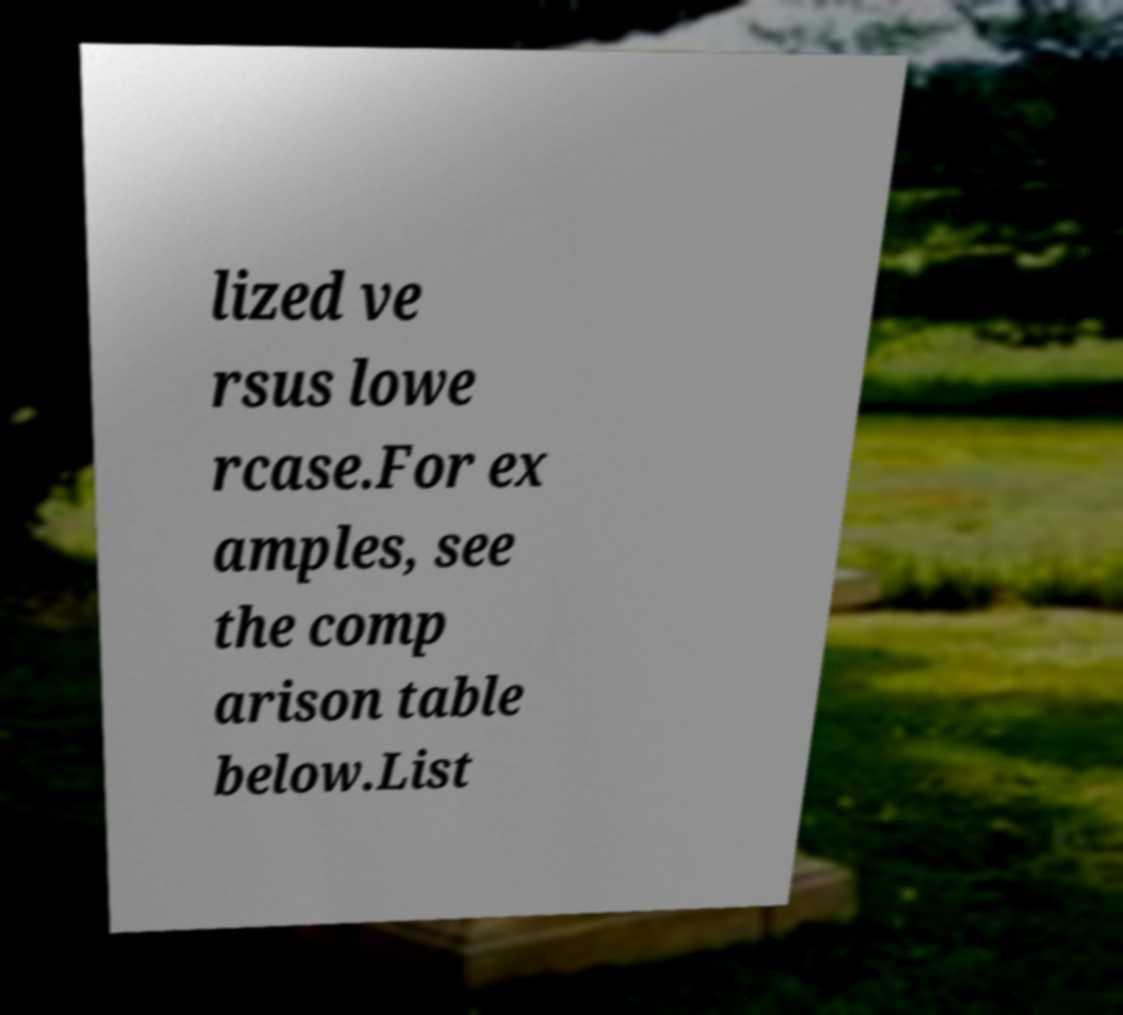Please read and relay the text visible in this image. What does it say? lized ve rsus lowe rcase.For ex amples, see the comp arison table below.List 